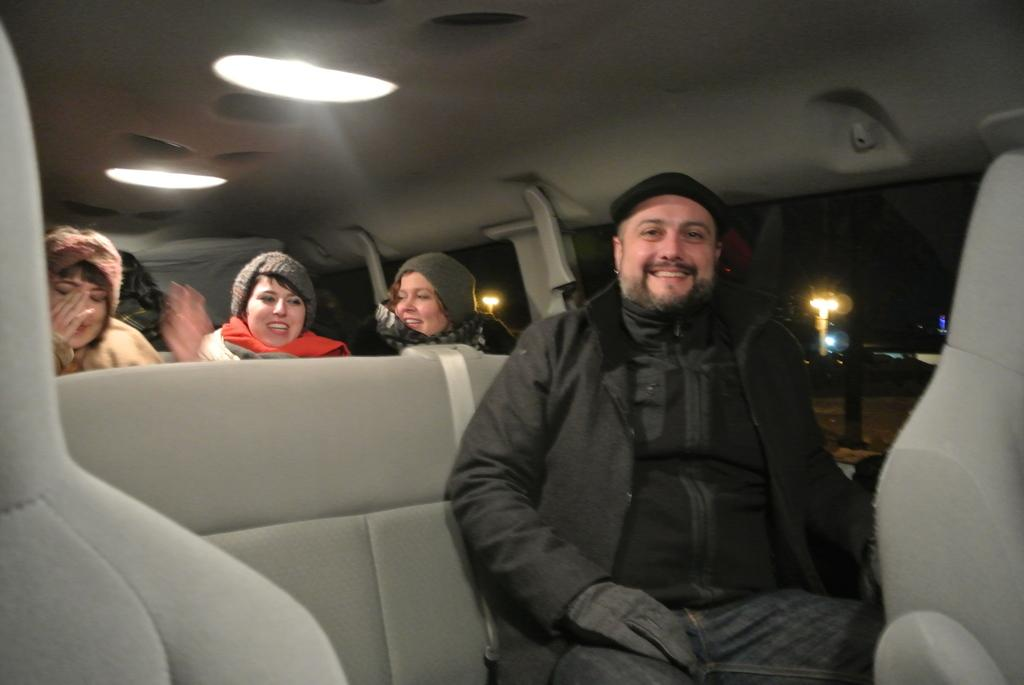How many persons are in the image? There are persons in the image. What are the persons doing in the image? The persons are smiling in the image. What are the persons sitting on in the image? The persons are sitting on chairs in the image. Where are the chairs located in the image? The chairs are inside a vehicle in the image. What can be seen in the image that provides light? There are lights in the image. What is the man wearing on his hands in the image? The man is wearing gloves on his hands in the image. What is the man wearing on his head in the image? The man is wearing a cap in the image. How many boys are writing in the image? There are no boys or writing present in the image. What type of hand is visible in the image? There is no specific hand mentioned in the image; only that a man is wearing gloves on his hands. 